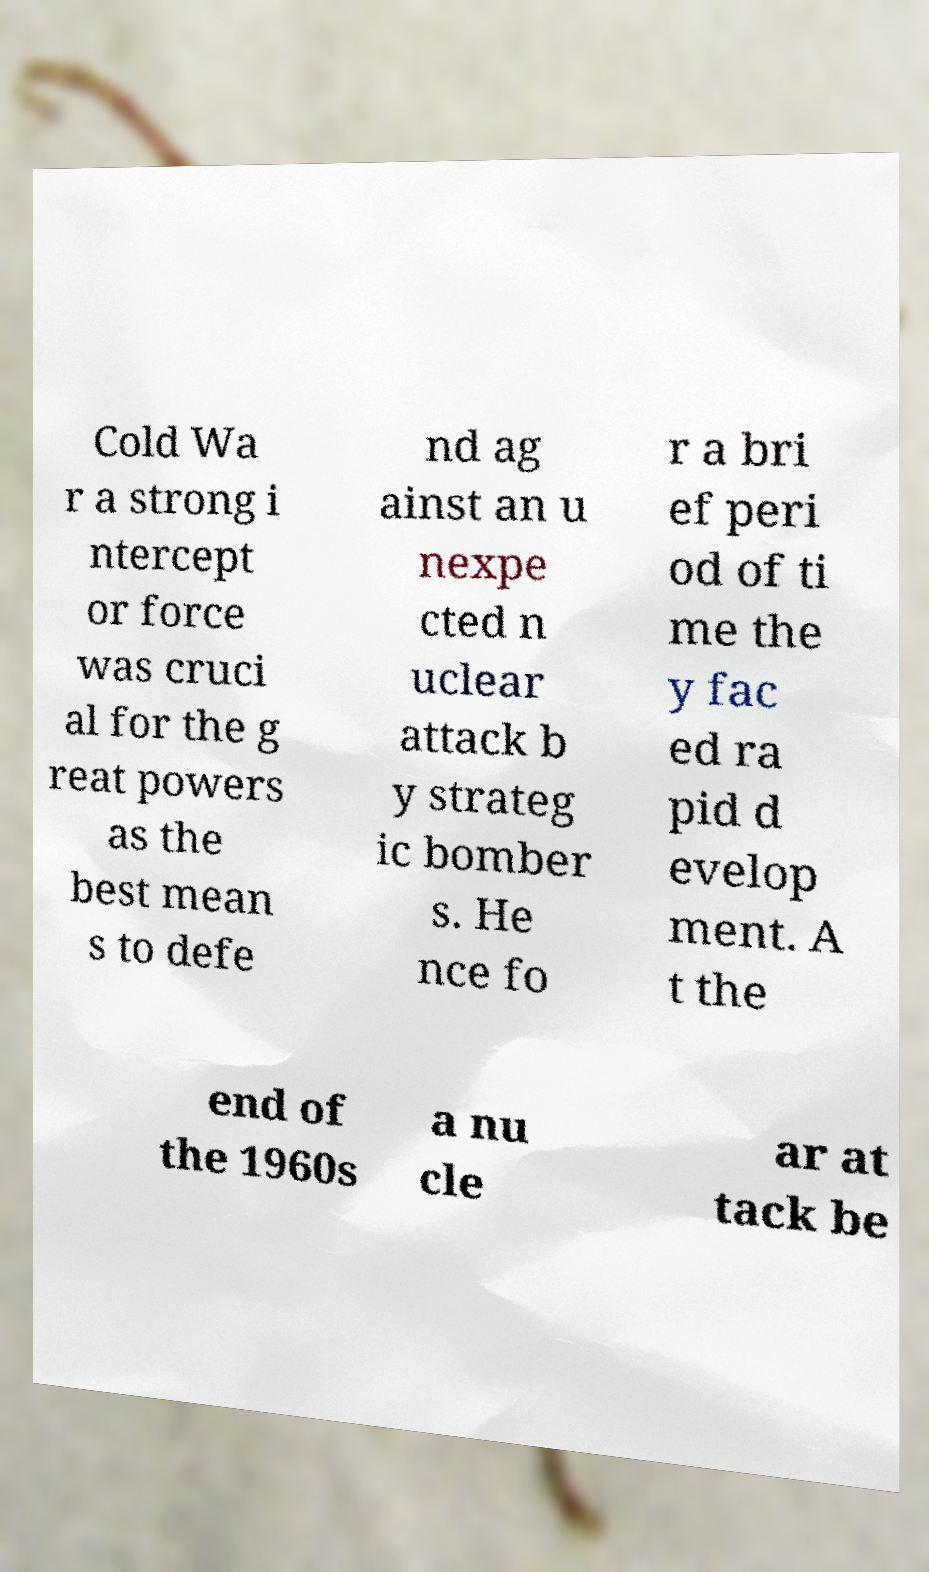I need the written content from this picture converted into text. Can you do that? Cold Wa r a strong i ntercept or force was cruci al for the g reat powers as the best mean s to defe nd ag ainst an u nexpe cted n uclear attack b y strateg ic bomber s. He nce fo r a bri ef peri od of ti me the y fac ed ra pid d evelop ment. A t the end of the 1960s a nu cle ar at tack be 